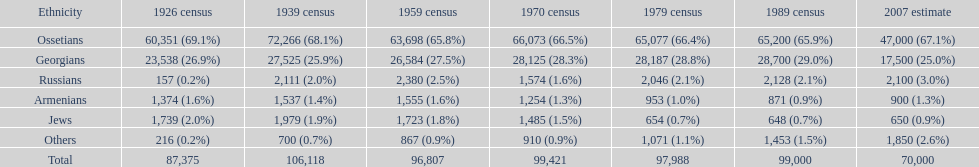Parse the full table. {'header': ['Ethnicity', '1926 census', '1939 census', '1959 census', '1970 census', '1979 census', '1989 census', '2007 estimate'], 'rows': [['Ossetians', '60,351 (69.1%)', '72,266 (68.1%)', '63,698 (65.8%)', '66,073 (66.5%)', '65,077 (66.4%)', '65,200 (65.9%)', '47,000 (67.1%)'], ['Georgians', '23,538 (26.9%)', '27,525 (25.9%)', '26,584 (27.5%)', '28,125 (28.3%)', '28,187 (28.8%)', '28,700 (29.0%)', '17,500 (25.0%)'], ['Russians', '157 (0.2%)', '2,111 (2.0%)', '2,380 (2.5%)', '1,574 (1.6%)', '2,046 (2.1%)', '2,128 (2.1%)', '2,100 (3.0%)'], ['Armenians', '1,374 (1.6%)', '1,537 (1.4%)', '1,555 (1.6%)', '1,254 (1.3%)', '953 (1.0%)', '871 (0.9%)', '900 (1.3%)'], ['Jews', '1,739 (2.0%)', '1,979 (1.9%)', '1,723 (1.8%)', '1,485 (1.5%)', '654 (0.7%)', '648 (0.7%)', '650 (0.9%)'], ['Others', '216 (0.2%)', '700 (0.7%)', '867 (0.9%)', '910 (0.9%)', '1,071 (1.1%)', '1,453 (1.5%)', '1,850 (2.6%)'], ['Total', '87,375', '106,118', '96,807', '99,421', '97,988', '99,000', '70,000']]} How many ethnicity is there? 6. 